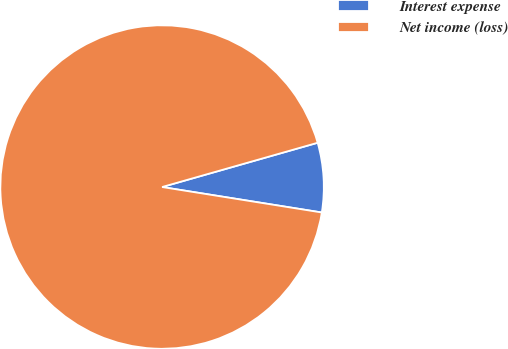<chart> <loc_0><loc_0><loc_500><loc_500><pie_chart><fcel>Interest expense<fcel>Net income (loss)<nl><fcel>6.93%<fcel>93.07%<nl></chart> 